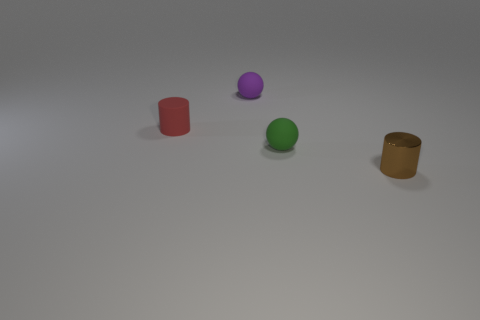Add 2 red cubes. How many objects exist? 6 Subtract all green spheres. How many spheres are left? 1 Subtract all purple balls. Subtract all cyan blocks. How many balls are left? 1 Subtract all brown blocks. How many blue balls are left? 0 Subtract all small blue matte blocks. Subtract all small green things. How many objects are left? 3 Add 1 tiny rubber cylinders. How many tiny rubber cylinders are left? 2 Add 1 balls. How many balls exist? 3 Subtract 0 blue spheres. How many objects are left? 4 Subtract 1 balls. How many balls are left? 1 